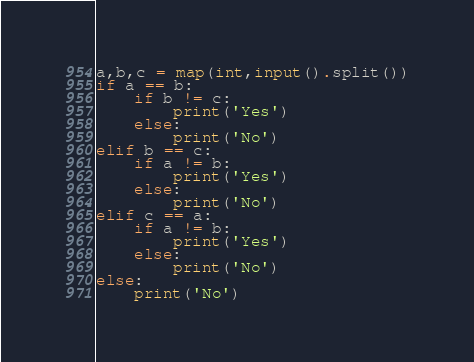<code> <loc_0><loc_0><loc_500><loc_500><_Python_>a,b,c = map(int,input().split())
if a == b:
    if b != c:
        print('Yes')
    else:
        print('No')
elif b == c:
    if a != b:
        print('Yes')
    else:
        print('No')
elif c == a:
    if a != b:
        print('Yes')
    else:
        print('No')
else:
    print('No')
</code> 